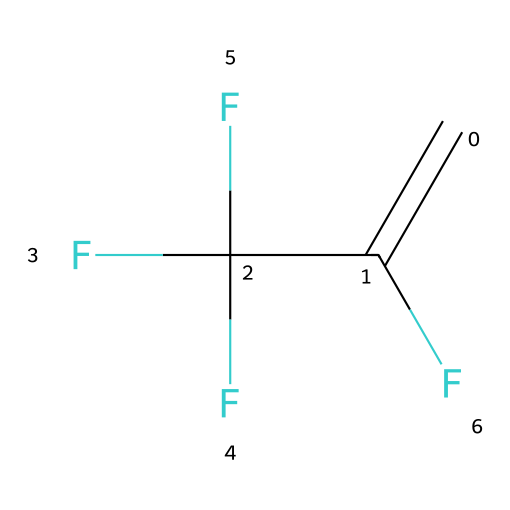What is the name of this chemical? The chemical structure corresponds to a compound known as R-1234yf, which is a fluorinated alkene used as a refrigerant.
Answer: R-1234yf How many fluorine atoms are in this molecule? By analyzing the SMILES representation, there are three occurrences of 'F', indicating there are three fluorine atoms in the structure.
Answer: 3 What type of chemical bonds are predominantly present in this structure? The SMILES representation indicates the presence of double bonds (C=C) and single bonds between carbon and fluorine atoms, predominantly featuring carbon-fluorine single bonds and a carbon-carbon double bond.
Answer: single and double What is the degree of unsaturation of R-1234yf? The formula for degree of unsaturation can be determined by the number of rings and double bonds in the structure; one double bond in the molecule indicates one degree of unsaturation.
Answer: 1 What is the main application of R-1234yf? R-1234yf is primarily used as a refrigerant in mobile air conditioning systems, replacing R-134a due to its lower global warming potential.
Answer: refrigerant Why is R-1234yf considered a next-generation refrigerant? R-1234yf has a much lower global warming potential (GWP) compared to traditional refrigerants, making it environmentally friendly and compliant with regulatory standards for emissions.
Answer: environmentally friendly 